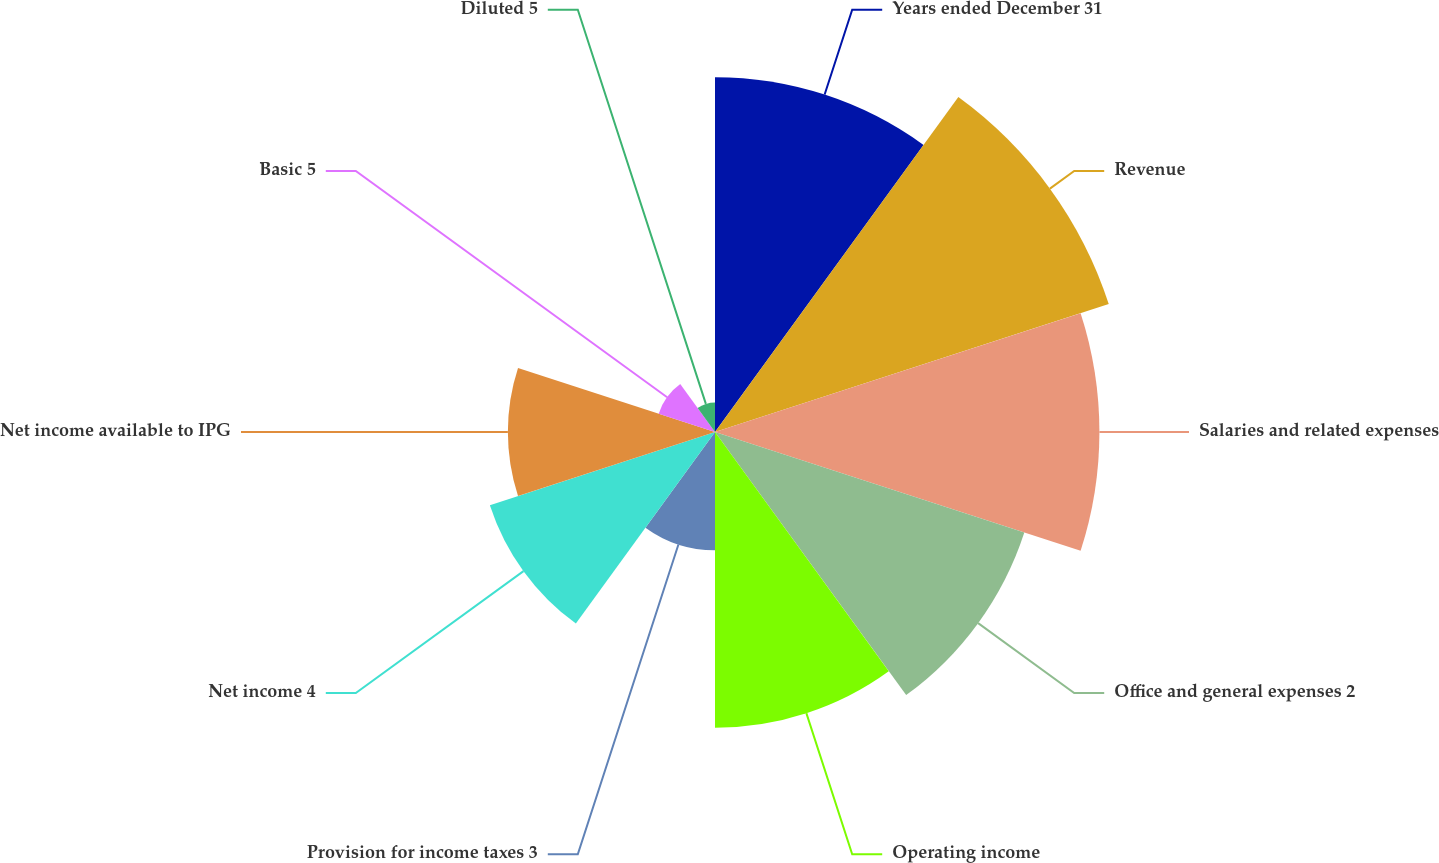Convert chart to OTSL. <chart><loc_0><loc_0><loc_500><loc_500><pie_chart><fcel>Years ended December 31<fcel>Revenue<fcel>Salaries and related expenses<fcel>Office and general expenses 2<fcel>Operating income<fcel>Provision for income taxes 3<fcel>Net income 4<fcel>Net income available to IPG<fcel>Basic 5<fcel>Diluted 5<nl><fcel>14.63%<fcel>17.07%<fcel>15.85%<fcel>13.41%<fcel>12.19%<fcel>4.88%<fcel>9.76%<fcel>8.54%<fcel>2.44%<fcel>1.22%<nl></chart> 